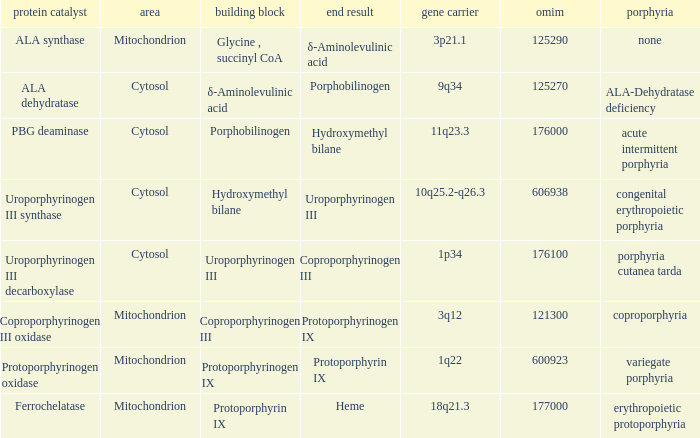What is protoporphyrin ix's substrate? Protoporphyrinogen IX. 